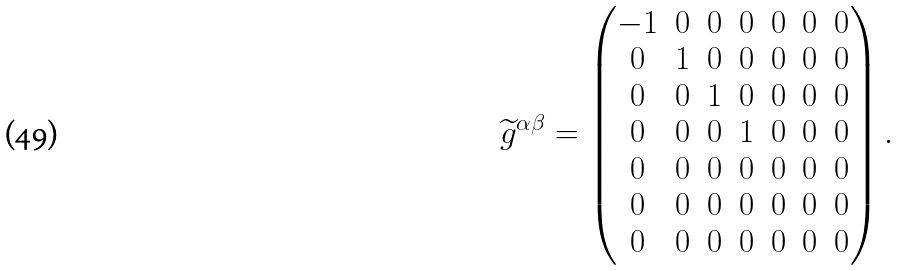<formula> <loc_0><loc_0><loc_500><loc_500>\widetilde { g } ^ { \alpha \beta } = \left ( \begin{matrix} - 1 & 0 & 0 & 0 & 0 & 0 & 0 \\ 0 & 1 & 0 & 0 & 0 & 0 & 0 \\ 0 & 0 & 1 & 0 & 0 & 0 & 0 \\ 0 & 0 & 0 & 1 & 0 & 0 & 0 \\ 0 & 0 & 0 & 0 & 0 & 0 & 0 \\ 0 & 0 & 0 & 0 & 0 & 0 & 0 \\ 0 & 0 & 0 & 0 & 0 & 0 & 0 \end{matrix} \right ) .</formula> 